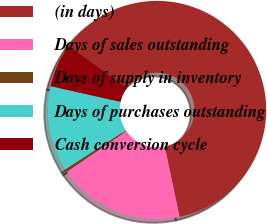Convert chart. <chart><loc_0><loc_0><loc_500><loc_500><pie_chart><fcel>(in days)<fcel>Days of sales outstanding<fcel>Days of supply in inventory<fcel>Days of purchases outstanding<fcel>Cash conversion cycle<nl><fcel>61.65%<fcel>18.77%<fcel>0.4%<fcel>12.65%<fcel>6.52%<nl></chart> 